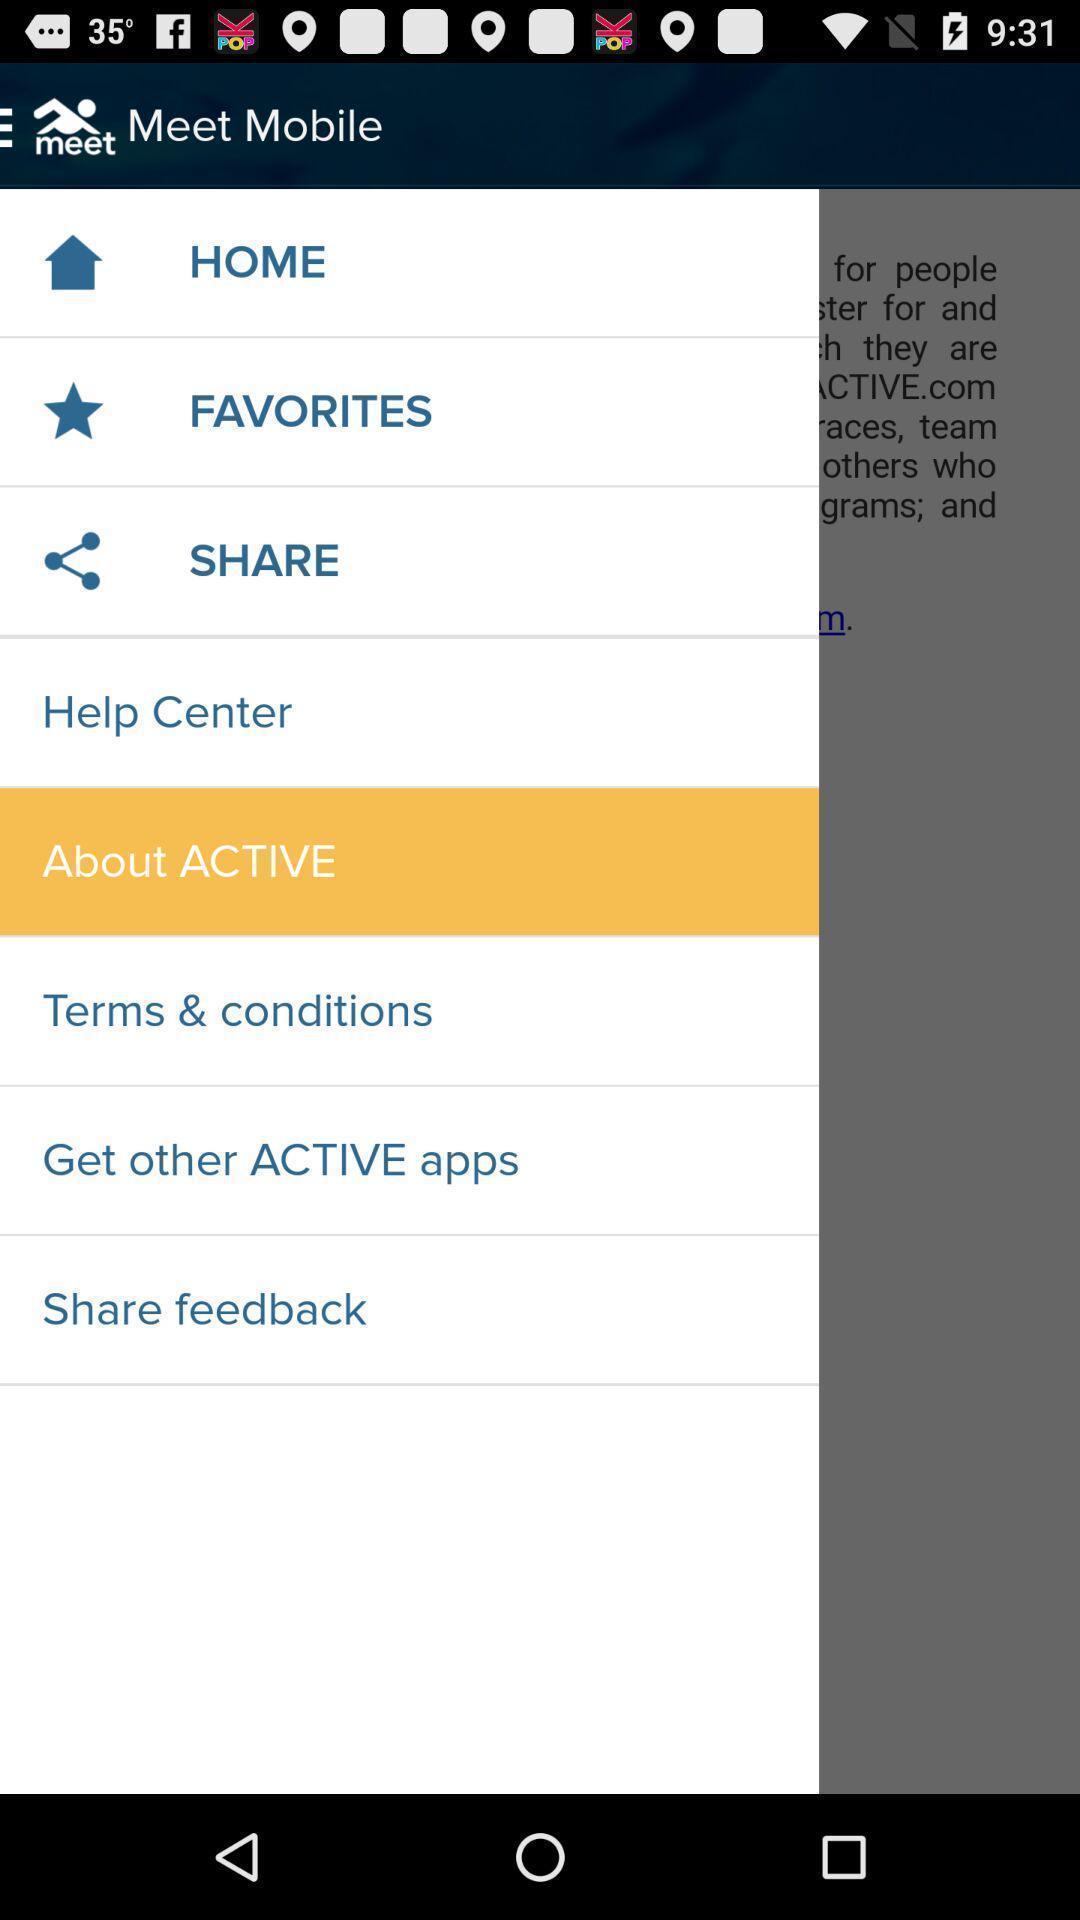Summarize the main components in this picture. Screen shows list of options in a communication app. 